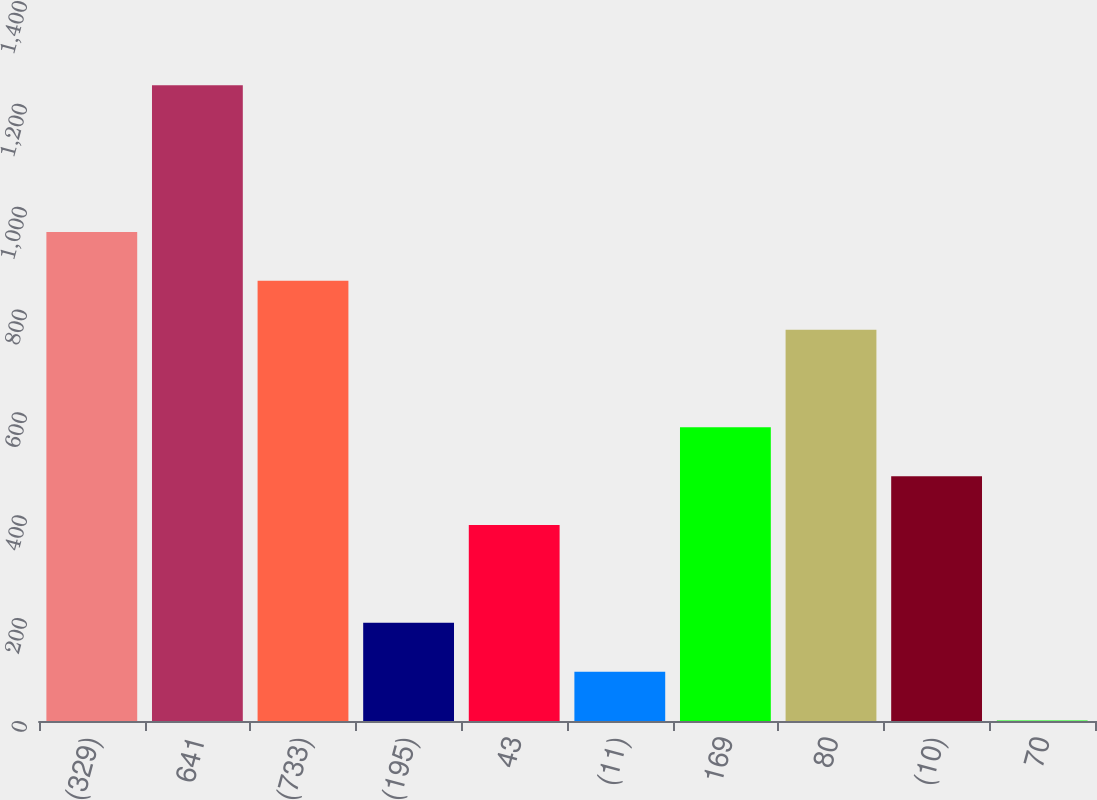Convert chart to OTSL. <chart><loc_0><loc_0><loc_500><loc_500><bar_chart><fcel>(329)<fcel>641<fcel>(733)<fcel>(195)<fcel>43<fcel>(11)<fcel>169<fcel>80<fcel>(10)<fcel>70<nl><fcel>951<fcel>1236<fcel>856<fcel>191<fcel>381<fcel>96<fcel>571<fcel>761<fcel>476<fcel>1<nl></chart> 